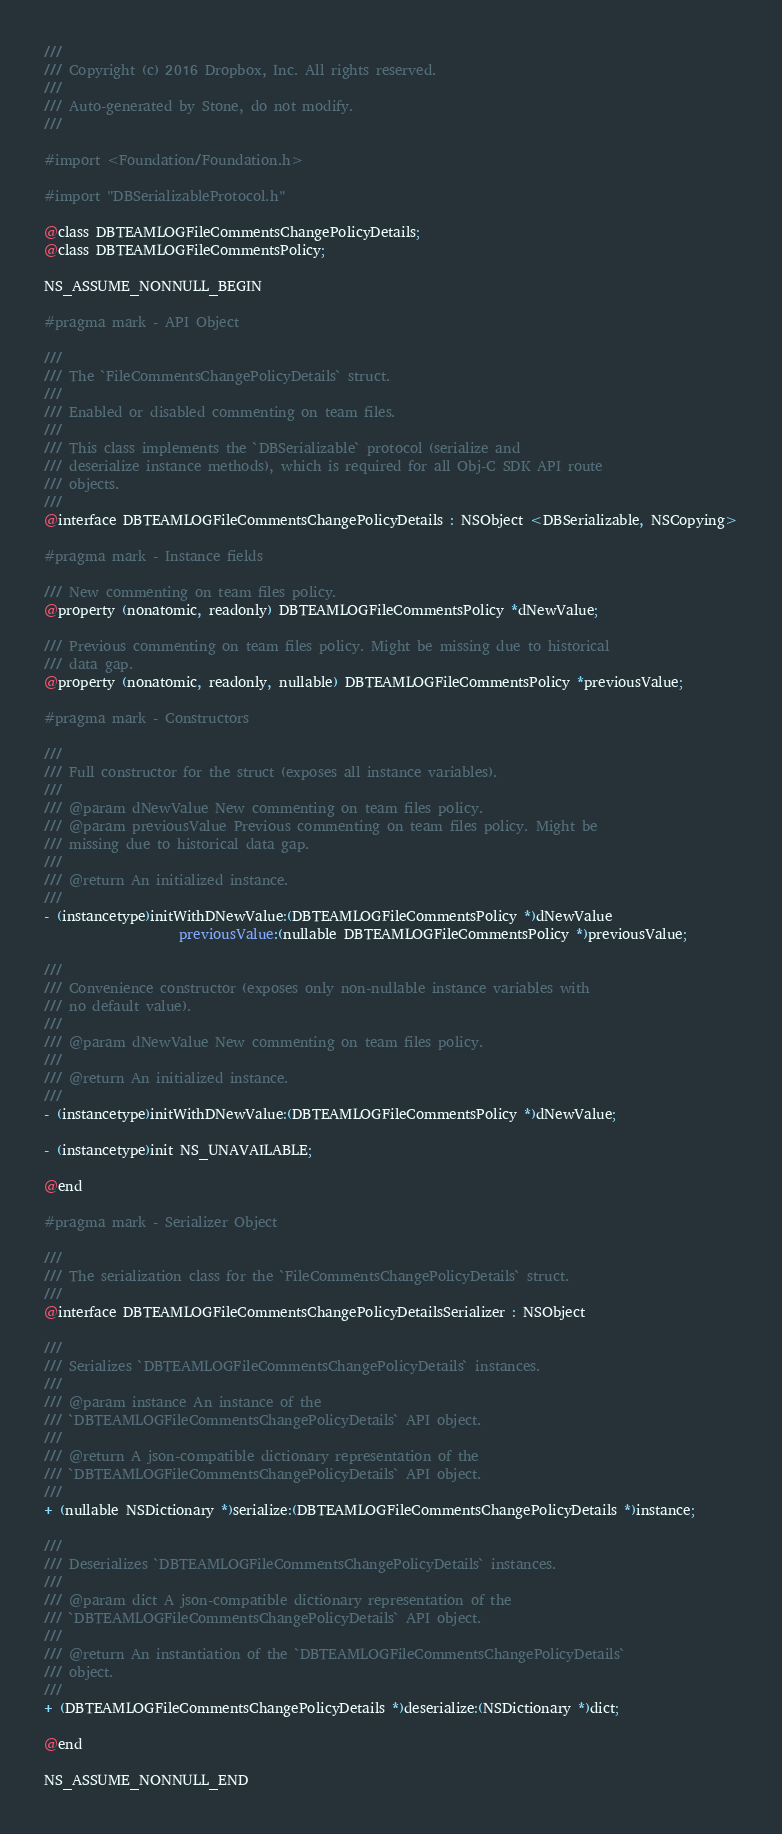Convert code to text. <code><loc_0><loc_0><loc_500><loc_500><_C_>///
/// Copyright (c) 2016 Dropbox, Inc. All rights reserved.
///
/// Auto-generated by Stone, do not modify.
///

#import <Foundation/Foundation.h>

#import "DBSerializableProtocol.h"

@class DBTEAMLOGFileCommentsChangePolicyDetails;
@class DBTEAMLOGFileCommentsPolicy;

NS_ASSUME_NONNULL_BEGIN

#pragma mark - API Object

///
/// The `FileCommentsChangePolicyDetails` struct.
///
/// Enabled or disabled commenting on team files.
///
/// This class implements the `DBSerializable` protocol (serialize and
/// deserialize instance methods), which is required for all Obj-C SDK API route
/// objects.
///
@interface DBTEAMLOGFileCommentsChangePolicyDetails : NSObject <DBSerializable, NSCopying>

#pragma mark - Instance fields

/// New commenting on team files policy.
@property (nonatomic, readonly) DBTEAMLOGFileCommentsPolicy *dNewValue;

/// Previous commenting on team files policy. Might be missing due to historical
/// data gap.
@property (nonatomic, readonly, nullable) DBTEAMLOGFileCommentsPolicy *previousValue;

#pragma mark - Constructors

///
/// Full constructor for the struct (exposes all instance variables).
///
/// @param dNewValue New commenting on team files policy.
/// @param previousValue Previous commenting on team files policy. Might be
/// missing due to historical data gap.
///
/// @return An initialized instance.
///
- (instancetype)initWithDNewValue:(DBTEAMLOGFileCommentsPolicy *)dNewValue
                    previousValue:(nullable DBTEAMLOGFileCommentsPolicy *)previousValue;

///
/// Convenience constructor (exposes only non-nullable instance variables with
/// no default value).
///
/// @param dNewValue New commenting on team files policy.
///
/// @return An initialized instance.
///
- (instancetype)initWithDNewValue:(DBTEAMLOGFileCommentsPolicy *)dNewValue;

- (instancetype)init NS_UNAVAILABLE;

@end

#pragma mark - Serializer Object

///
/// The serialization class for the `FileCommentsChangePolicyDetails` struct.
///
@interface DBTEAMLOGFileCommentsChangePolicyDetailsSerializer : NSObject

///
/// Serializes `DBTEAMLOGFileCommentsChangePolicyDetails` instances.
///
/// @param instance An instance of the
/// `DBTEAMLOGFileCommentsChangePolicyDetails` API object.
///
/// @return A json-compatible dictionary representation of the
/// `DBTEAMLOGFileCommentsChangePolicyDetails` API object.
///
+ (nullable NSDictionary *)serialize:(DBTEAMLOGFileCommentsChangePolicyDetails *)instance;

///
/// Deserializes `DBTEAMLOGFileCommentsChangePolicyDetails` instances.
///
/// @param dict A json-compatible dictionary representation of the
/// `DBTEAMLOGFileCommentsChangePolicyDetails` API object.
///
/// @return An instantiation of the `DBTEAMLOGFileCommentsChangePolicyDetails`
/// object.
///
+ (DBTEAMLOGFileCommentsChangePolicyDetails *)deserialize:(NSDictionary *)dict;

@end

NS_ASSUME_NONNULL_END
</code> 